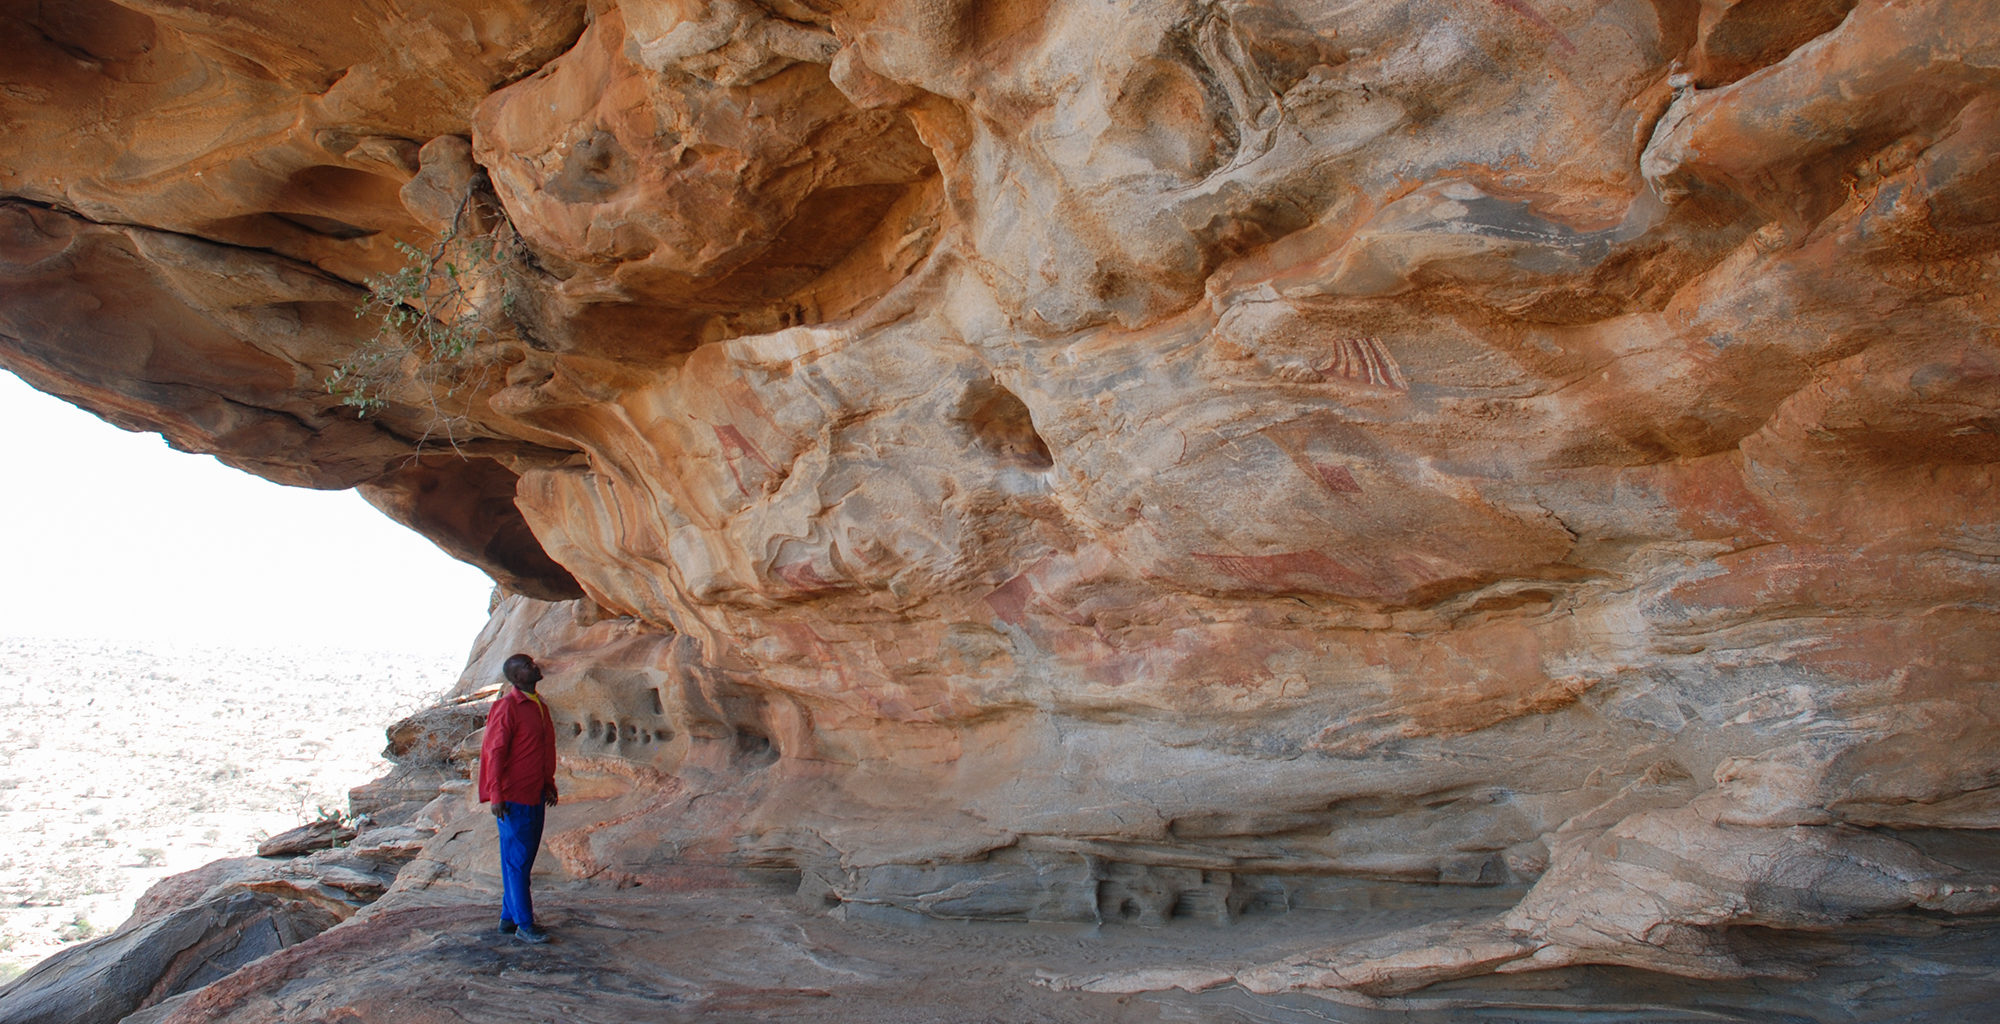Share a brief story of an explorer discovering this place for the first time. An intrepid explorer named Dr. Elena Davis, driven by a passion for uncovering lost histories, ventures into the arid landscape of Somaliland. After days of enduring the relentless desert sun and navigating rugged terrain, she stumbles upon the entrance to Laas Geel. Her heart races as she steps into the shaded refuge of the cave. She's initially struck by the cool air, a stark contrast to the blazing outside, and then by the breathtaking sight of the ancient rock art. Overwhelmed with awe and a sense of mission fulfillment, Dr. Davis realizes that she is standing in a place where history, art, and life itself intersect. She meticulously documents the site, ensuring the preservation of this incredible chapter of human history for future generations. 